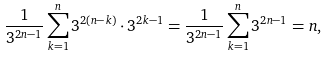<formula> <loc_0><loc_0><loc_500><loc_500>\frac { 1 } { 3 ^ { 2 n - 1 } } \sum _ { k = 1 } ^ { n } 3 ^ { 2 ( n - k ) } \cdot 3 ^ { 2 k - 1 } = \frac { 1 } { 3 ^ { 2 n - 1 } } \sum _ { k = 1 } ^ { n } 3 ^ { 2 n - 1 } = n ,</formula> 